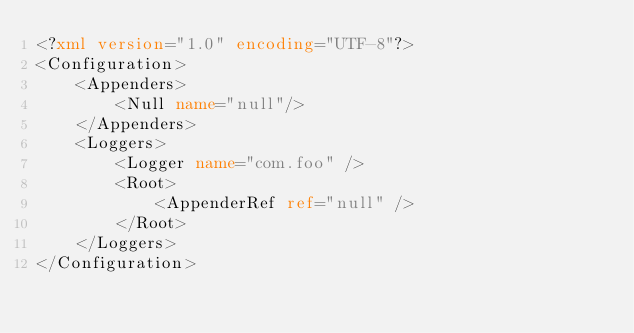Convert code to text. <code><loc_0><loc_0><loc_500><loc_500><_XML_><?xml version="1.0" encoding="UTF-8"?>
<Configuration>
    <Appenders>
        <Null name="null"/>
    </Appenders>
    <Loggers>
        <Logger name="com.foo" />
        <Root>
            <AppenderRef ref="null" />
        </Root>
    </Loggers>
</Configuration></code> 